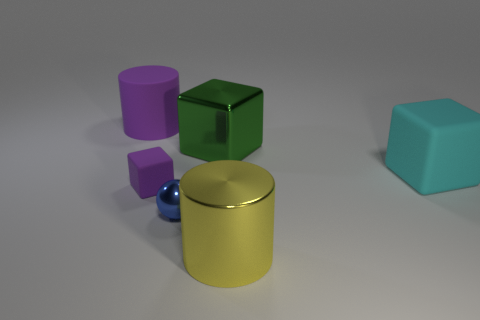Add 2 tiny spheres. How many objects exist? 8 Subtract all cylinders. How many objects are left? 4 Add 6 big brown matte things. How many big brown matte things exist? 6 Subtract 0 cyan balls. How many objects are left? 6 Subtract all balls. Subtract all yellow objects. How many objects are left? 4 Add 1 large purple objects. How many large purple objects are left? 2 